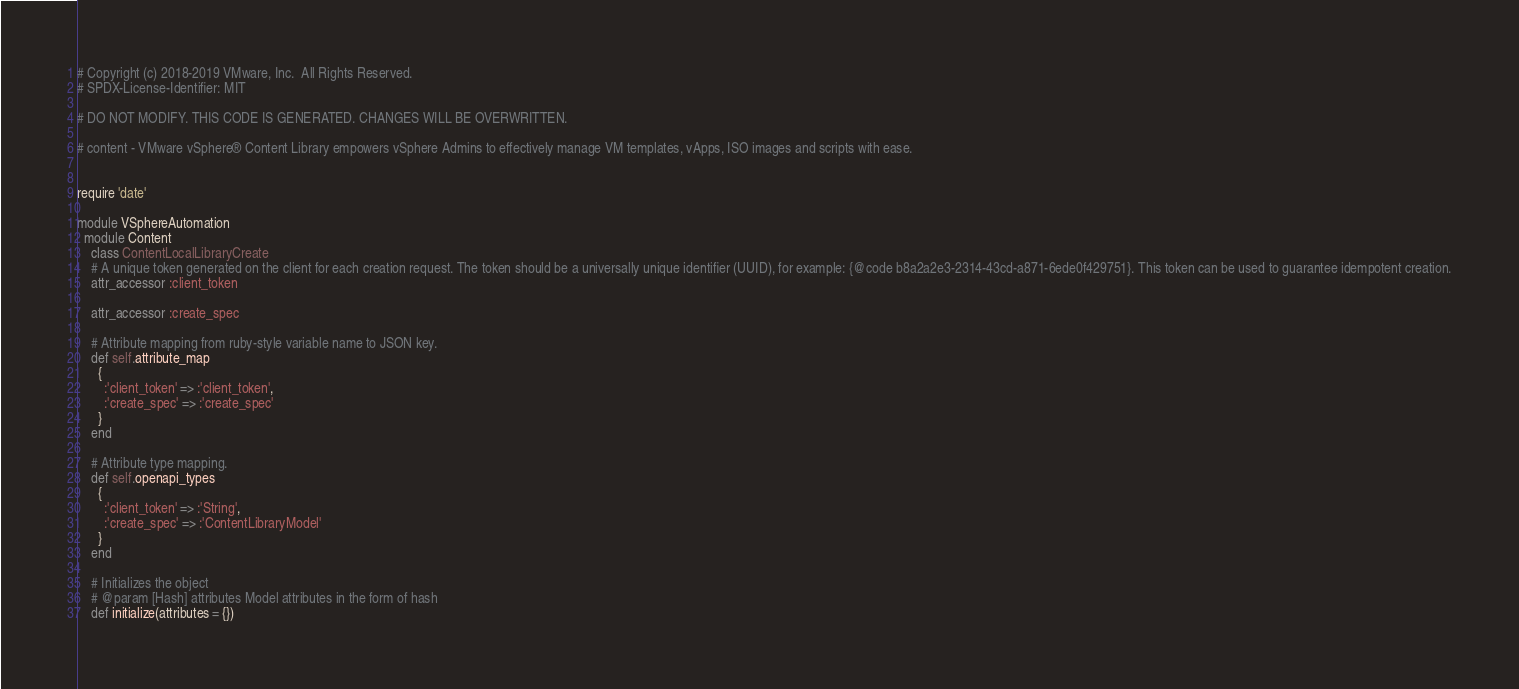Convert code to text. <code><loc_0><loc_0><loc_500><loc_500><_Ruby_># Copyright (c) 2018-2019 VMware, Inc.  All Rights Reserved.
# SPDX-License-Identifier: MIT

# DO NOT MODIFY. THIS CODE IS GENERATED. CHANGES WILL BE OVERWRITTEN.

# content - VMware vSphere® Content Library empowers vSphere Admins to effectively manage VM templates, vApps, ISO images and scripts with ease.


require 'date'

module VSphereAutomation
  module Content
    class ContentLocalLibraryCreate
    # A unique token generated on the client for each creation request. The token should be a universally unique identifier (UUID), for example: {@code b8a2a2e3-2314-43cd-a871-6ede0f429751}. This token can be used to guarantee idempotent creation.
    attr_accessor :client_token

    attr_accessor :create_spec

    # Attribute mapping from ruby-style variable name to JSON key.
    def self.attribute_map
      {
        :'client_token' => :'client_token',
        :'create_spec' => :'create_spec'
      }
    end

    # Attribute type mapping.
    def self.openapi_types
      {
        :'client_token' => :'String',
        :'create_spec' => :'ContentLibraryModel'
      }
    end

    # Initializes the object
    # @param [Hash] attributes Model attributes in the form of hash
    def initialize(attributes = {})</code> 